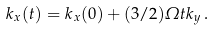<formula> <loc_0><loc_0><loc_500><loc_500>k _ { x } ( t ) = k _ { x } ( 0 ) + ( 3 / 2 ) \varOmega t k _ { y } \, .</formula> 